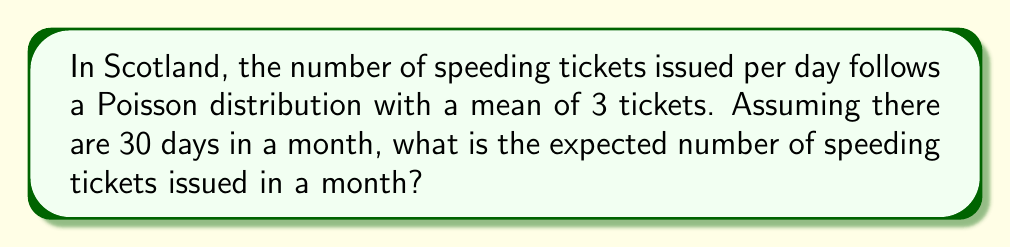What is the answer to this math problem? Let's approach this step-by-step:

1) First, we need to understand what the Poisson distribution tells us. If X is a Poisson random variable with mean λ, then:

   $E[X] = λ$

   where E[X] is the expected value of X.

2) In this case, we're told that the mean number of tickets per day is 3. So for a single day:

   $E[X_{day}] = 3$

3) Now, we need to find the expected number for a month. We're assuming 30 days in a month.

4) A key property of expected values is linearity. This means that:

   $E[X_1 + X_2 + ... + X_n] = E[X_1] + E[X_2] + ... + E[X_n]$

5) Applying this to our problem, if we let $X_{month}$ be the number of tickets in a month:

   $E[X_{month}] = E[X_{day1} + X_{day2} + ... + X_{day30}]$
                 $= E[X_{day1}] + E[X_{day2}] + ... + E[X_{day30}]$

6) Since each day has the same expected value of 3:

   $E[X_{month}] = 3 + 3 + ... + 3$ (30 times)
                 $= 30 * 3$
                 $= 90$

Therefore, the expected number of speeding tickets issued in a month is 90.
Answer: 90 tickets 